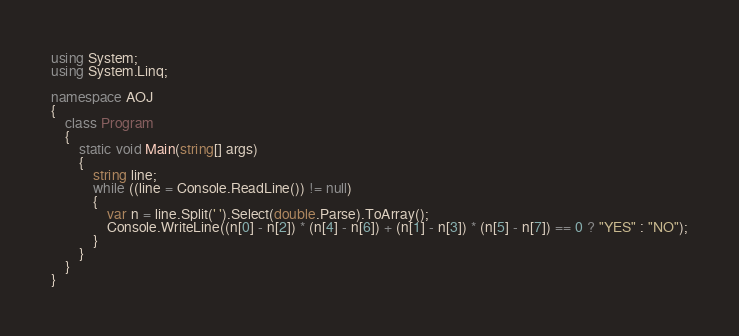<code> <loc_0><loc_0><loc_500><loc_500><_C#_>using System;
using System.Linq;

namespace AOJ
{
    class Program
    {
        static void Main(string[] args)
        {
            string line;
            while ((line = Console.ReadLine()) != null)
            {
                var n = line.Split(' ').Select(double.Parse).ToArray();
                Console.WriteLine((n[0] - n[2]) * (n[4] - n[6]) + (n[1] - n[3]) * (n[5] - n[7]) == 0 ? "YES" : "NO");
            }
        }
    }
}</code> 